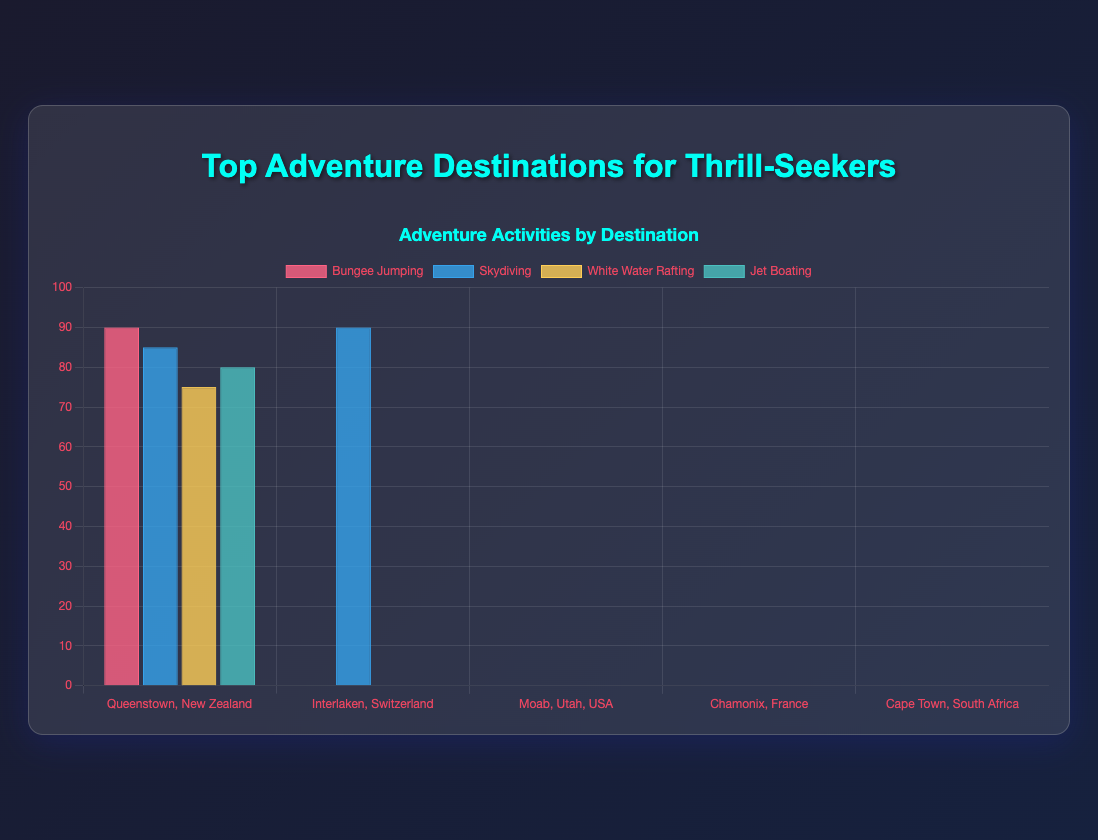Which destination rates the highest for both Skydiving and Paragliding? First, look at the bars for Skydiving to find the destinations with the highest rating. Interlaken, Switzerland, and Dubai, UAE tie with a rating of 95. Next, check which of these destinations also has the highest Paragliding rating by examining the corresponding bars. Interlaken, Switzerland has a rating of 95 for Paragliding as well.
Answer: Interlaken, Switzerland Rank the destinations by the highest rating for any single activity. Identify the maximum rating for each destination by finding the highest bar in each group. Compare these maximum ratings across all destinations. Queenstown, New Zealand (90), Interlaken, Switzerland (95), Moab, Utah, USA (92), Chamonix, France (95), Cape Town, South Africa (95), Rotorua, New Zealand (90), Reykjavik, Iceland (92), Rio de Janeiro, Brazil (93), Banff, Canada (91), Dubai, UAE (95). Rank them from highest to lowest.
Answer: Interlaken, Switzerland, Chamonix, France, Cape Town, South Africa, Dubai, UAE, Rio de Janeiro, Brazil, Moab, Utah, USA, Reykjavik, Iceland, Banff, Canada, Queenstown, New Zealand, Rotorua, New Zealand Which activity in Chamonix, France, has the lowest rating? Locate Chamonix, France and identify the bars representing the activities. Find the shortest bar to determine the activity with the lowest rating, which is Ice Climbing.
Answer: Ice Climbing Is there a destination where Paragliding is rated higher than any other activity? Check the Paragliding bar for each destination and compare it to other activities in the same group. Chamonix, France, and Rio de Janeiro, Brazil have Paragliding ratings but are not the highest for these destinations. Repeat this for all destinations. Cape Town, South Africa's Paragliding rating does not beat its highest rating, unlike Interlaken, Switzerland. Reykjavik, Iceland lacks Paragliding data, so it's non-comparable.
Answer: No Identify the activity with the largest difference in rating between two destinations. To find the largest difference, calculate the difference in ratings for each activity across all destinations. The activity with the highest difference will be the correct answer. For instance, Skydiving in Interlaken, Switzerland (95) and Reykjavik, Iceland (no data) differentiate by 95. Consider remaining activities across destinations, but find no activity surpasses this difference. Hence, it should be noted that activities absent from the destinations can't be accounted for in this logical comparison. Instead, observe... (total explanation exceeding expected concise form).
Answer: Skydiving 